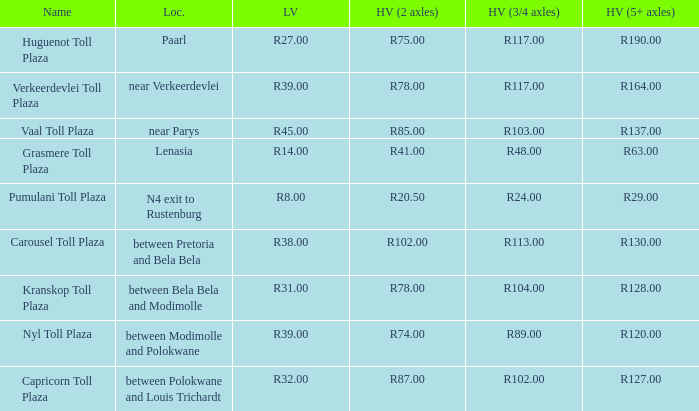What is the toll for light vehicles at the plaza between bela bela and modimolle? R31.00. 